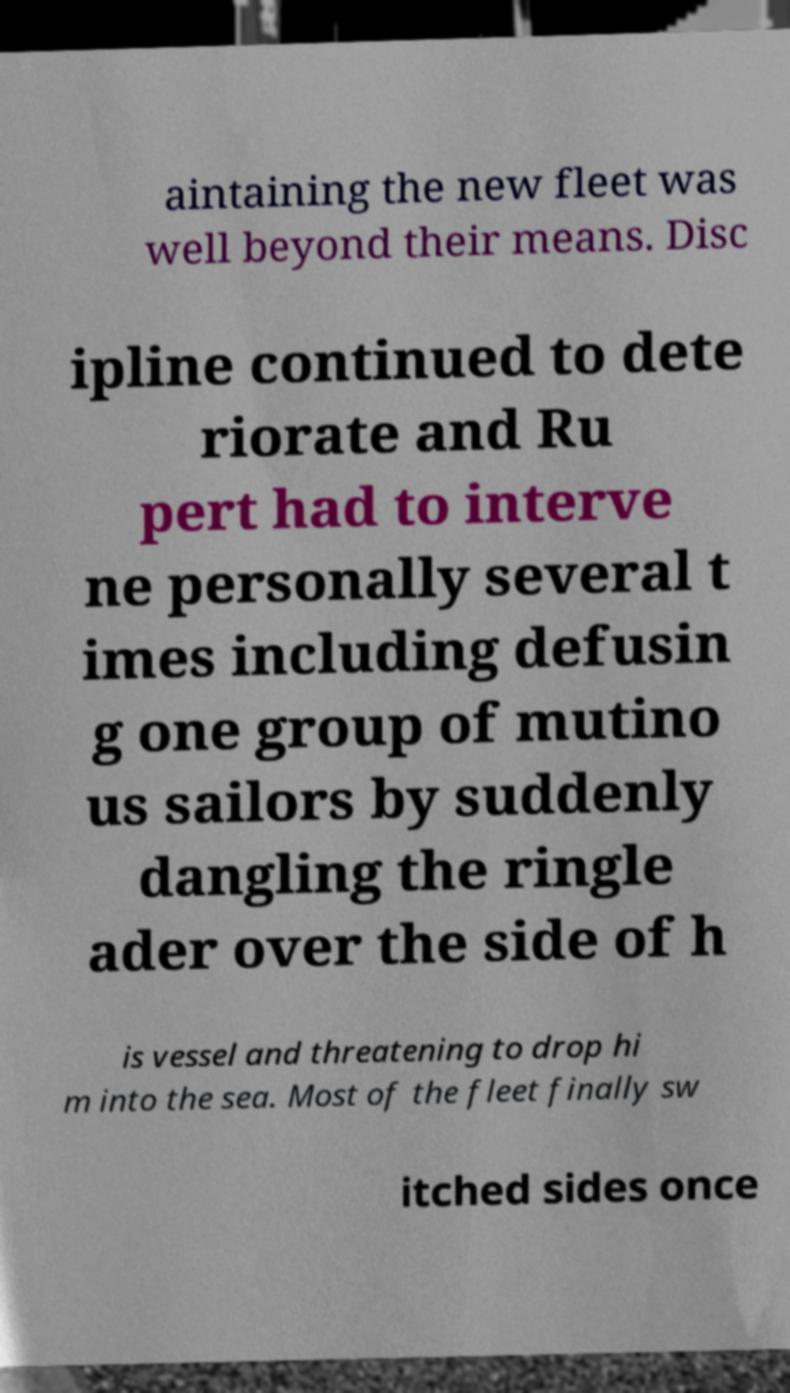Can you accurately transcribe the text from the provided image for me? aintaining the new fleet was well beyond their means. Disc ipline continued to dete riorate and Ru pert had to interve ne personally several t imes including defusin g one group of mutino us sailors by suddenly dangling the ringle ader over the side of h is vessel and threatening to drop hi m into the sea. Most of the fleet finally sw itched sides once 